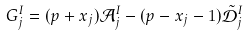<formula> <loc_0><loc_0><loc_500><loc_500>G _ { j } ^ { I } = ( p + x _ { j } ) { \mathcal { A } } ^ { I } _ { j } - ( p - x _ { j } - 1 ) \tilde { \mathcal { D } } _ { j } ^ { I }</formula> 